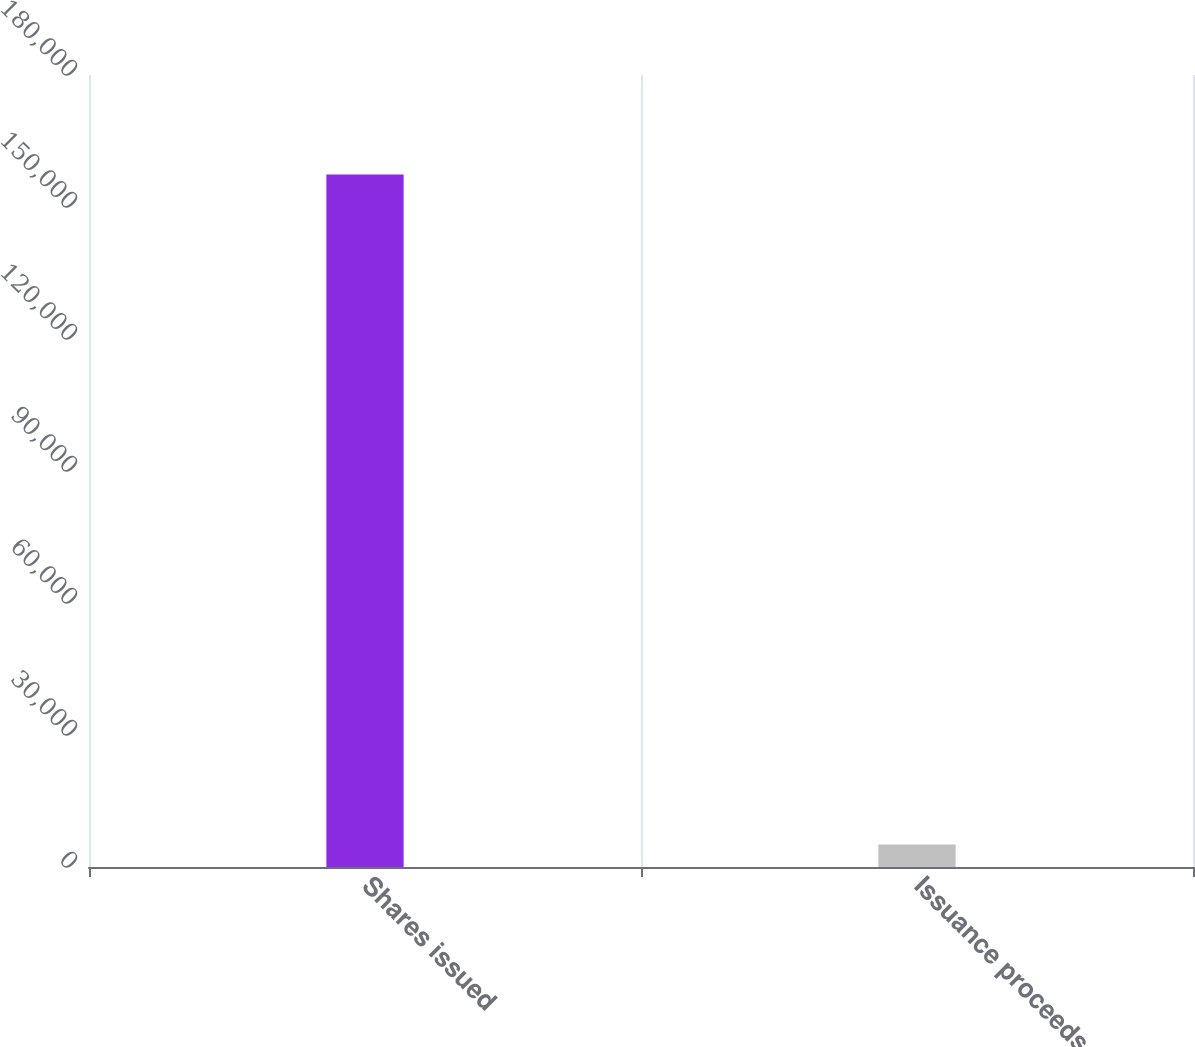Convert chart. <chart><loc_0><loc_0><loc_500><loc_500><bar_chart><fcel>Shares issued<fcel>Issuance proceeds<nl><fcel>157363<fcel>5112<nl></chart> 